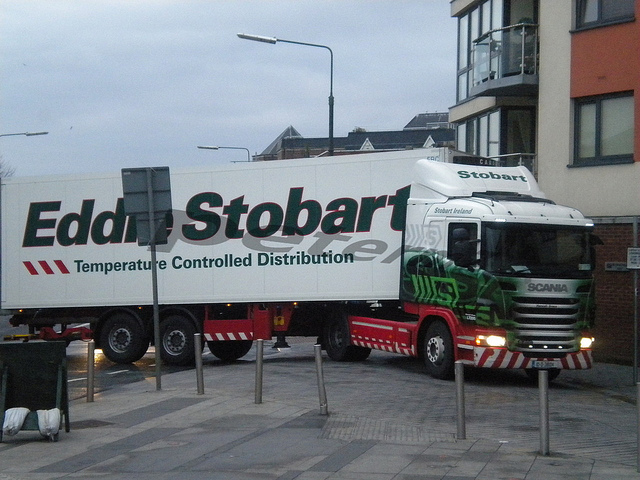How many doors in this? Based on the angle from which the photo was taken, there is one visible door on the side of the truck cabin. However, it is standard for trucks to have a door on each side of the cabin, so there is likely another door on the opposite side that is not visible in this image. 